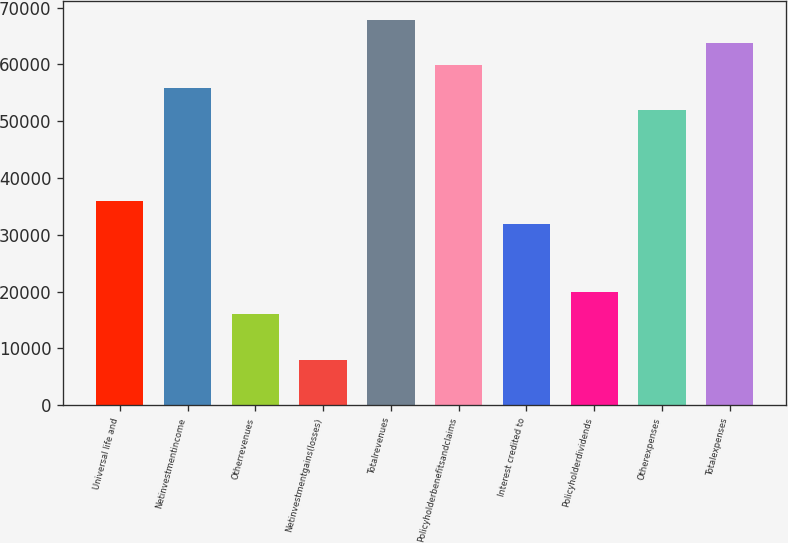<chart> <loc_0><loc_0><loc_500><loc_500><bar_chart><fcel>Universal life and<fcel>Netinvestmentincome<fcel>Otherrevenues<fcel>Netinvestmentgains(losses)<fcel>Totalrevenues<fcel>Policyholderbenefitsandclaims<fcel>Interest credited to<fcel>Policyholderdividends<fcel>Otherexpenses<fcel>Totalexpenses<nl><fcel>35935.2<fcel>55864.2<fcel>16006.2<fcel>8034.6<fcel>67821.6<fcel>59850<fcel>31949.4<fcel>19992<fcel>51878.4<fcel>63835.8<nl></chart> 